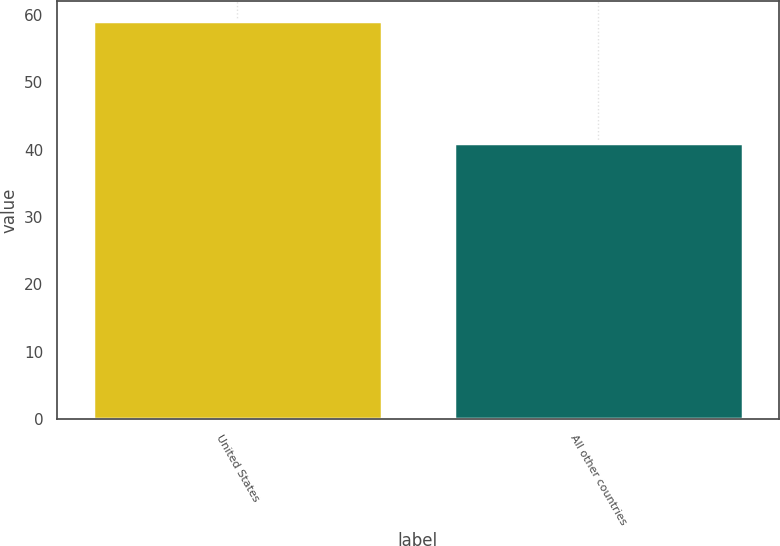<chart> <loc_0><loc_0><loc_500><loc_500><bar_chart><fcel>United States<fcel>All other countries<nl><fcel>59<fcel>41<nl></chart> 